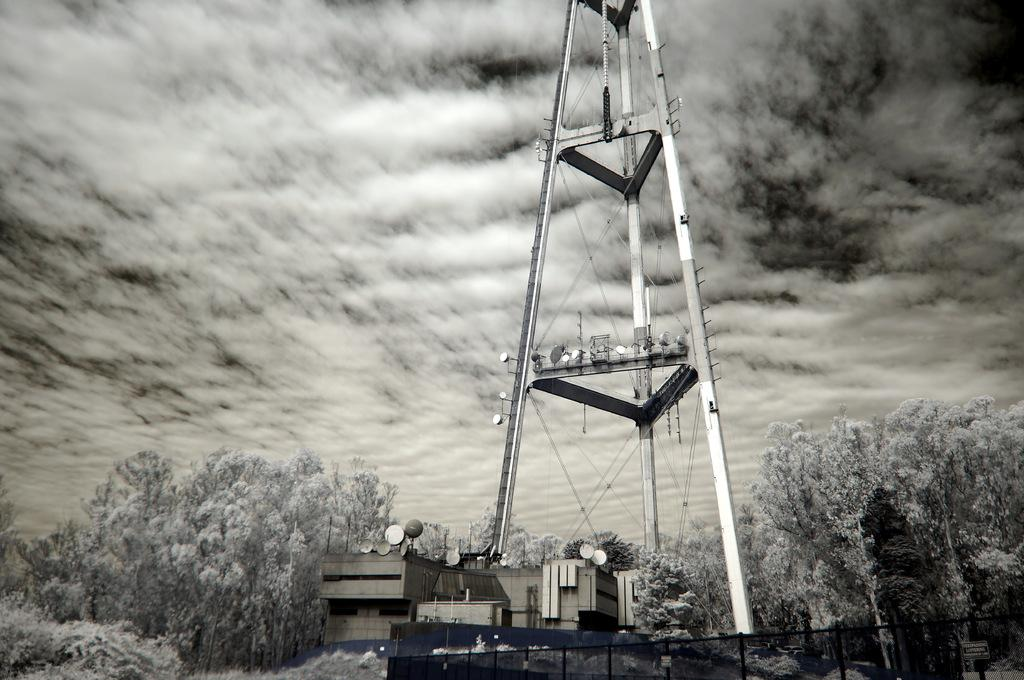What is the main structure in the image? There is a tower in the image. What is located below the tower? There is a building below the tower. What type of vegetation is present on either side of the tower? There are trees on either side of the tower. What can be seen in the right corner of the image? There is a fence in the right corner of the image. How would you describe the weather based on the sky in the image? The sky is cloudy in the image. Can you tell me how the stranger is involved in the battle depicted in the image? There is no stranger or battle depicted in the image; it features a tower, a building, trees, a fence, and a cloudy sky. 